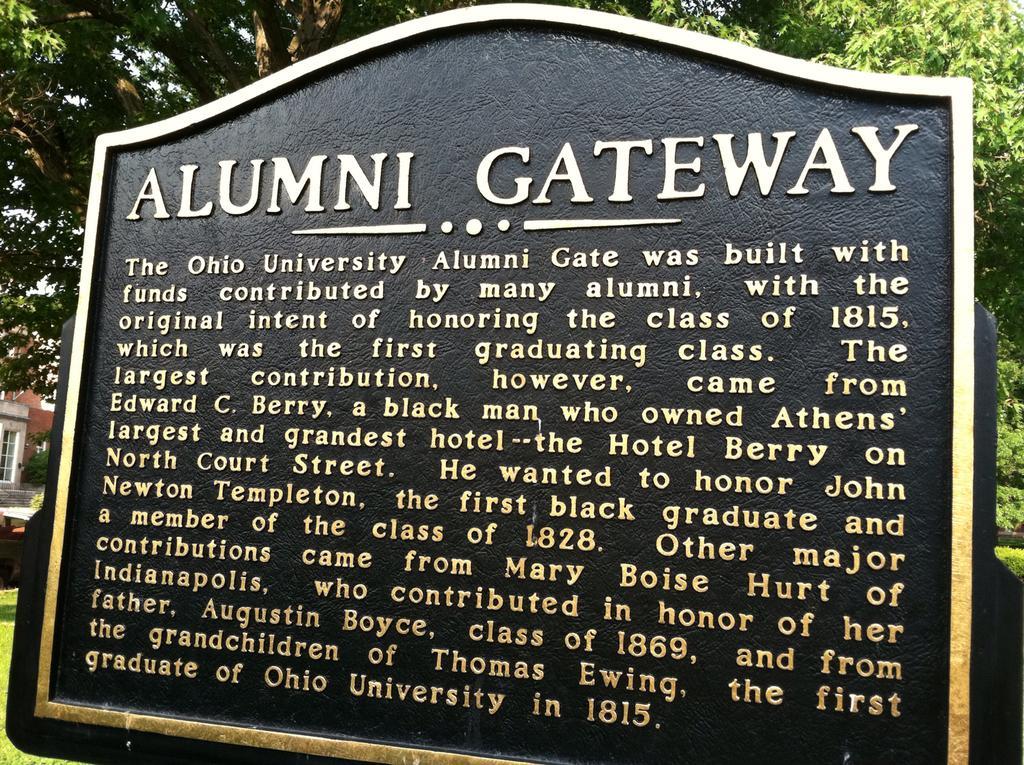Describe this image in one or two sentences. In this image we can see a house and it is having an entrance at the left side of the image. There is an object at the left side of the image. There are many trees in the image. There is a memorial stone and some text written on it in the image. There is a grassy land in the image. 